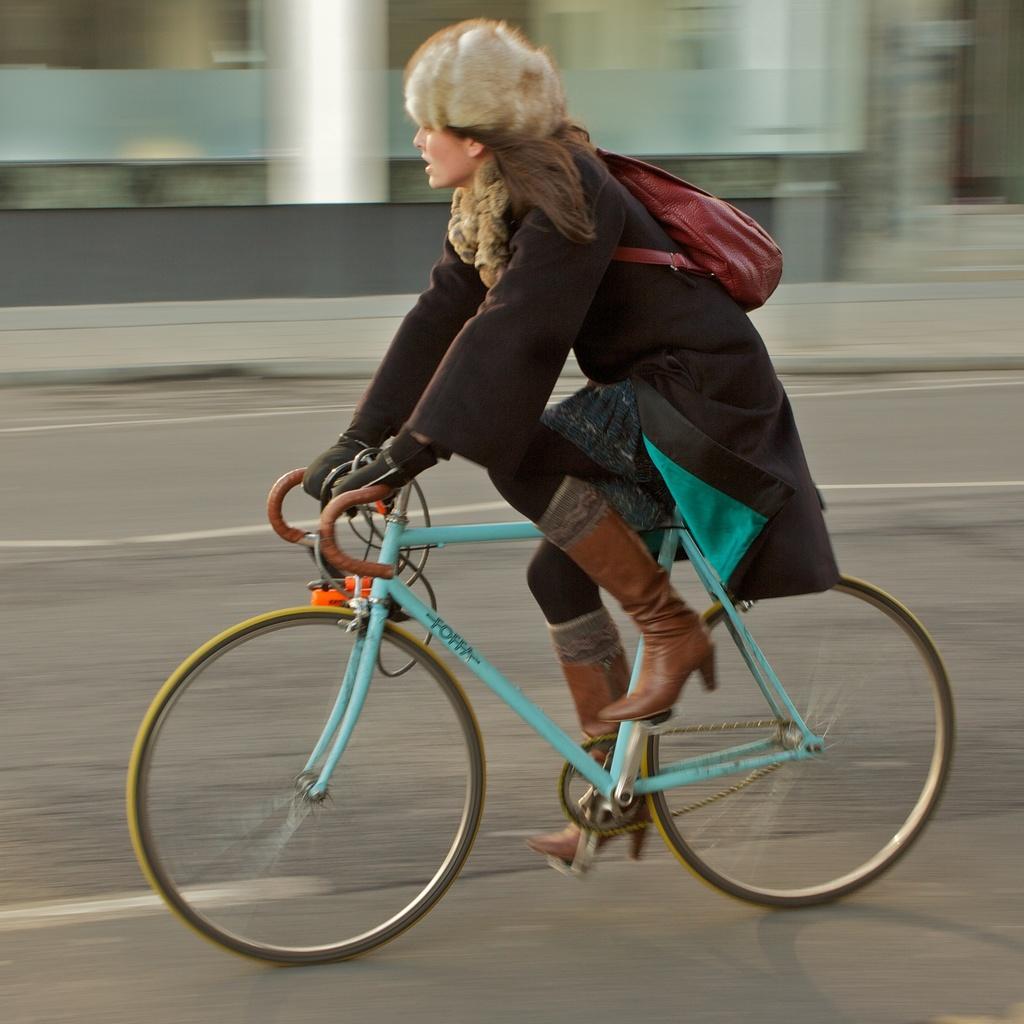Can you describe this image briefly? In this image the women is riding a bicycle on road wearing a backpack and a black coat. At the background we can see a building. 